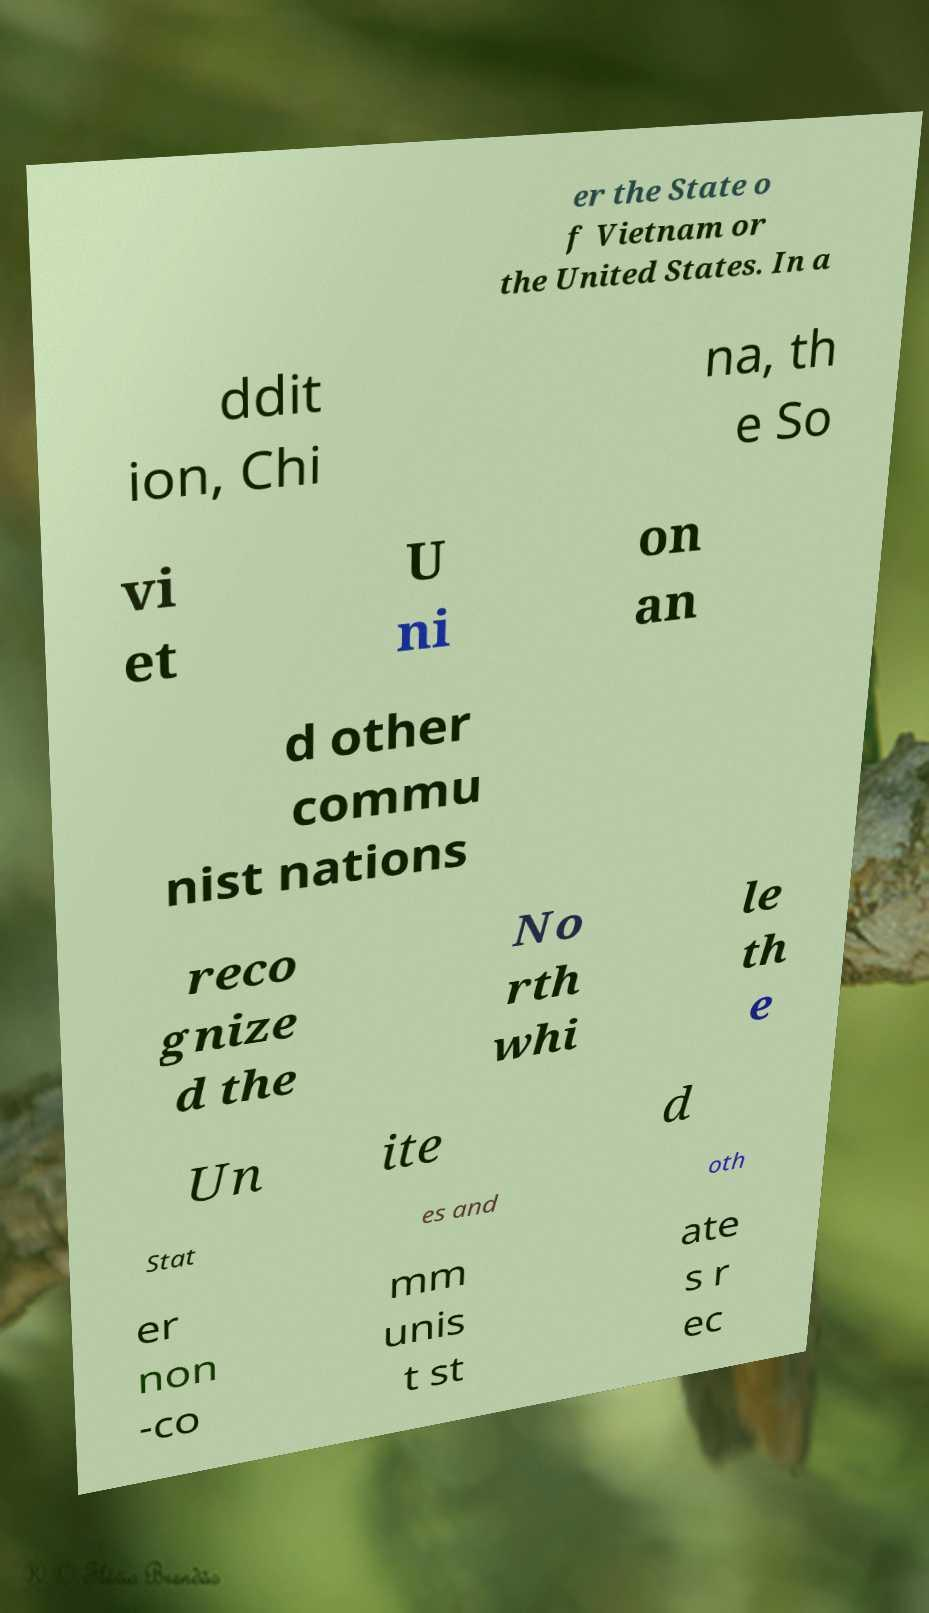There's text embedded in this image that I need extracted. Can you transcribe it verbatim? er the State o f Vietnam or the United States. In a ddit ion, Chi na, th e So vi et U ni on an d other commu nist nations reco gnize d the No rth whi le th e Un ite d Stat es and oth er non -co mm unis t st ate s r ec 